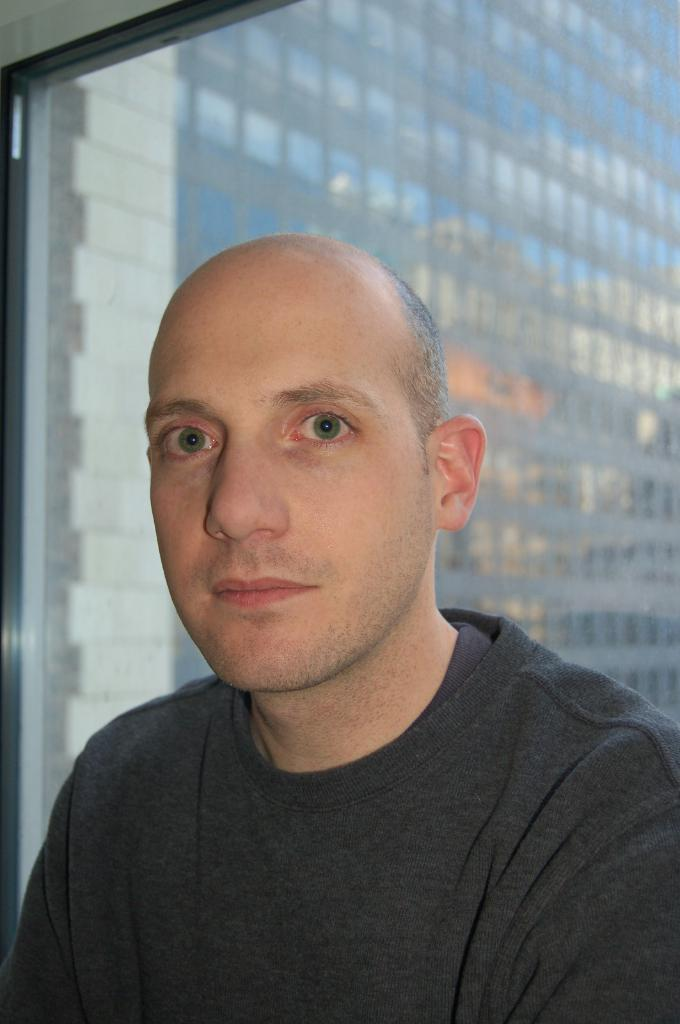Who or what is present in the image? There is a person in the image. What is the person wearing? The person is wearing a black t-shirt. What type of architectural feature is present in the image? There is a glass window in the image. What can be seen through the glass window? Another building is visible through the glass window. Reasoning: Let'g: Let's think step by step in order to produce the conversation. We start by identifying the main subject in the image, which is the person. Then, we describe the person's clothing to provide more detail. Next, we mention the glass window as an important architectural feature in the image. Finally, we describe what can be seen through the window to give context to the setting. Absurd Question/Answer: What type of creature can be seen flying in the sky in the image? There is no creature or sky visible in the image; it only shows a person, a black t-shirt, and a glass window with another building visible through it. 